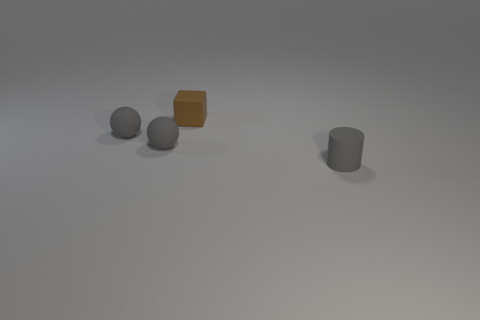Can you describe the colors and shapes of the objects presented in the image? Certainly! There are four objects in the image, which include two spherical objects, one cube, and one cylinder. The spheres and the cylinder appear to be a shade of grey, while the cube is distinctly brown in color. 